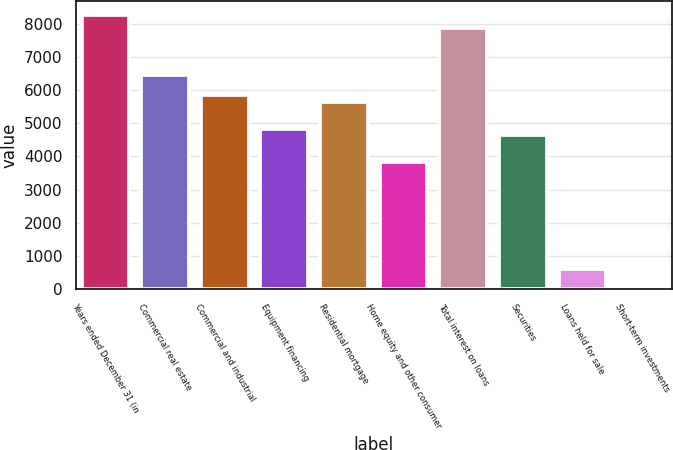<chart> <loc_0><loc_0><loc_500><loc_500><bar_chart><fcel>Years ended December 31 (in<fcel>Commercial real estate<fcel>Commercial and industrial<fcel>Equipment financing<fcel>Residential mortgage<fcel>Home equity and other consumer<fcel>Total interest on loans<fcel>Securities<fcel>Loans held for sale<fcel>Short-term investments<nl><fcel>8259.95<fcel>6446.9<fcel>5842.55<fcel>4835.3<fcel>5641.1<fcel>3828.05<fcel>7857.05<fcel>4633.85<fcel>604.85<fcel>0.5<nl></chart> 